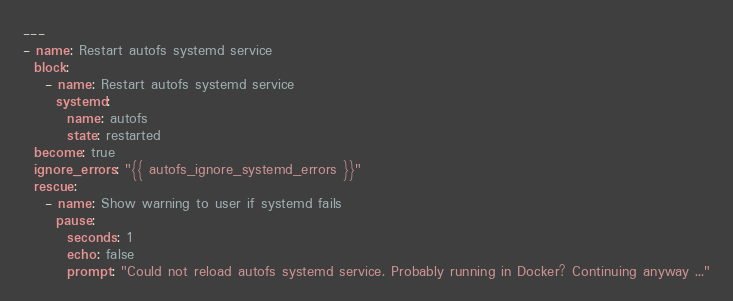<code> <loc_0><loc_0><loc_500><loc_500><_YAML_>---
- name: Restart autofs systemd service
  block:
    - name: Restart autofs systemd service
      systemd:
        name: autofs
        state: restarted
  become: true
  ignore_errors: "{{ autofs_ignore_systemd_errors }}"
  rescue:
    - name: Show warning to user if systemd fails
      pause:
        seconds: 1
        echo: false
        prompt: "Could not reload autofs systemd service. Probably running in Docker? Continuing anyway ..."
</code> 